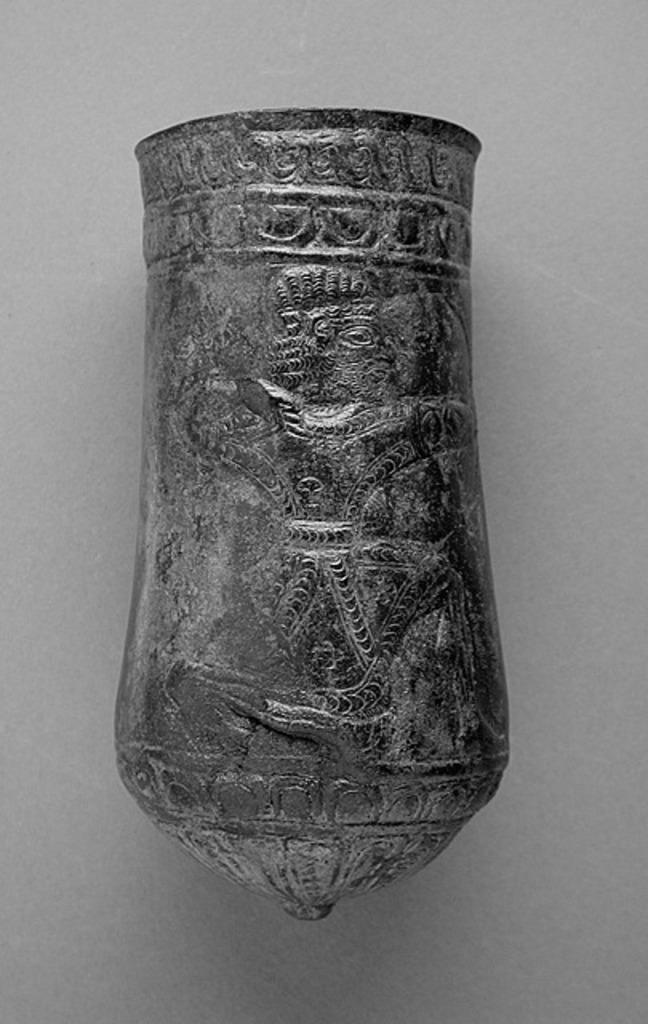Could you give a brief overview of what you see in this image? In this image, we can see an object on the surface. 